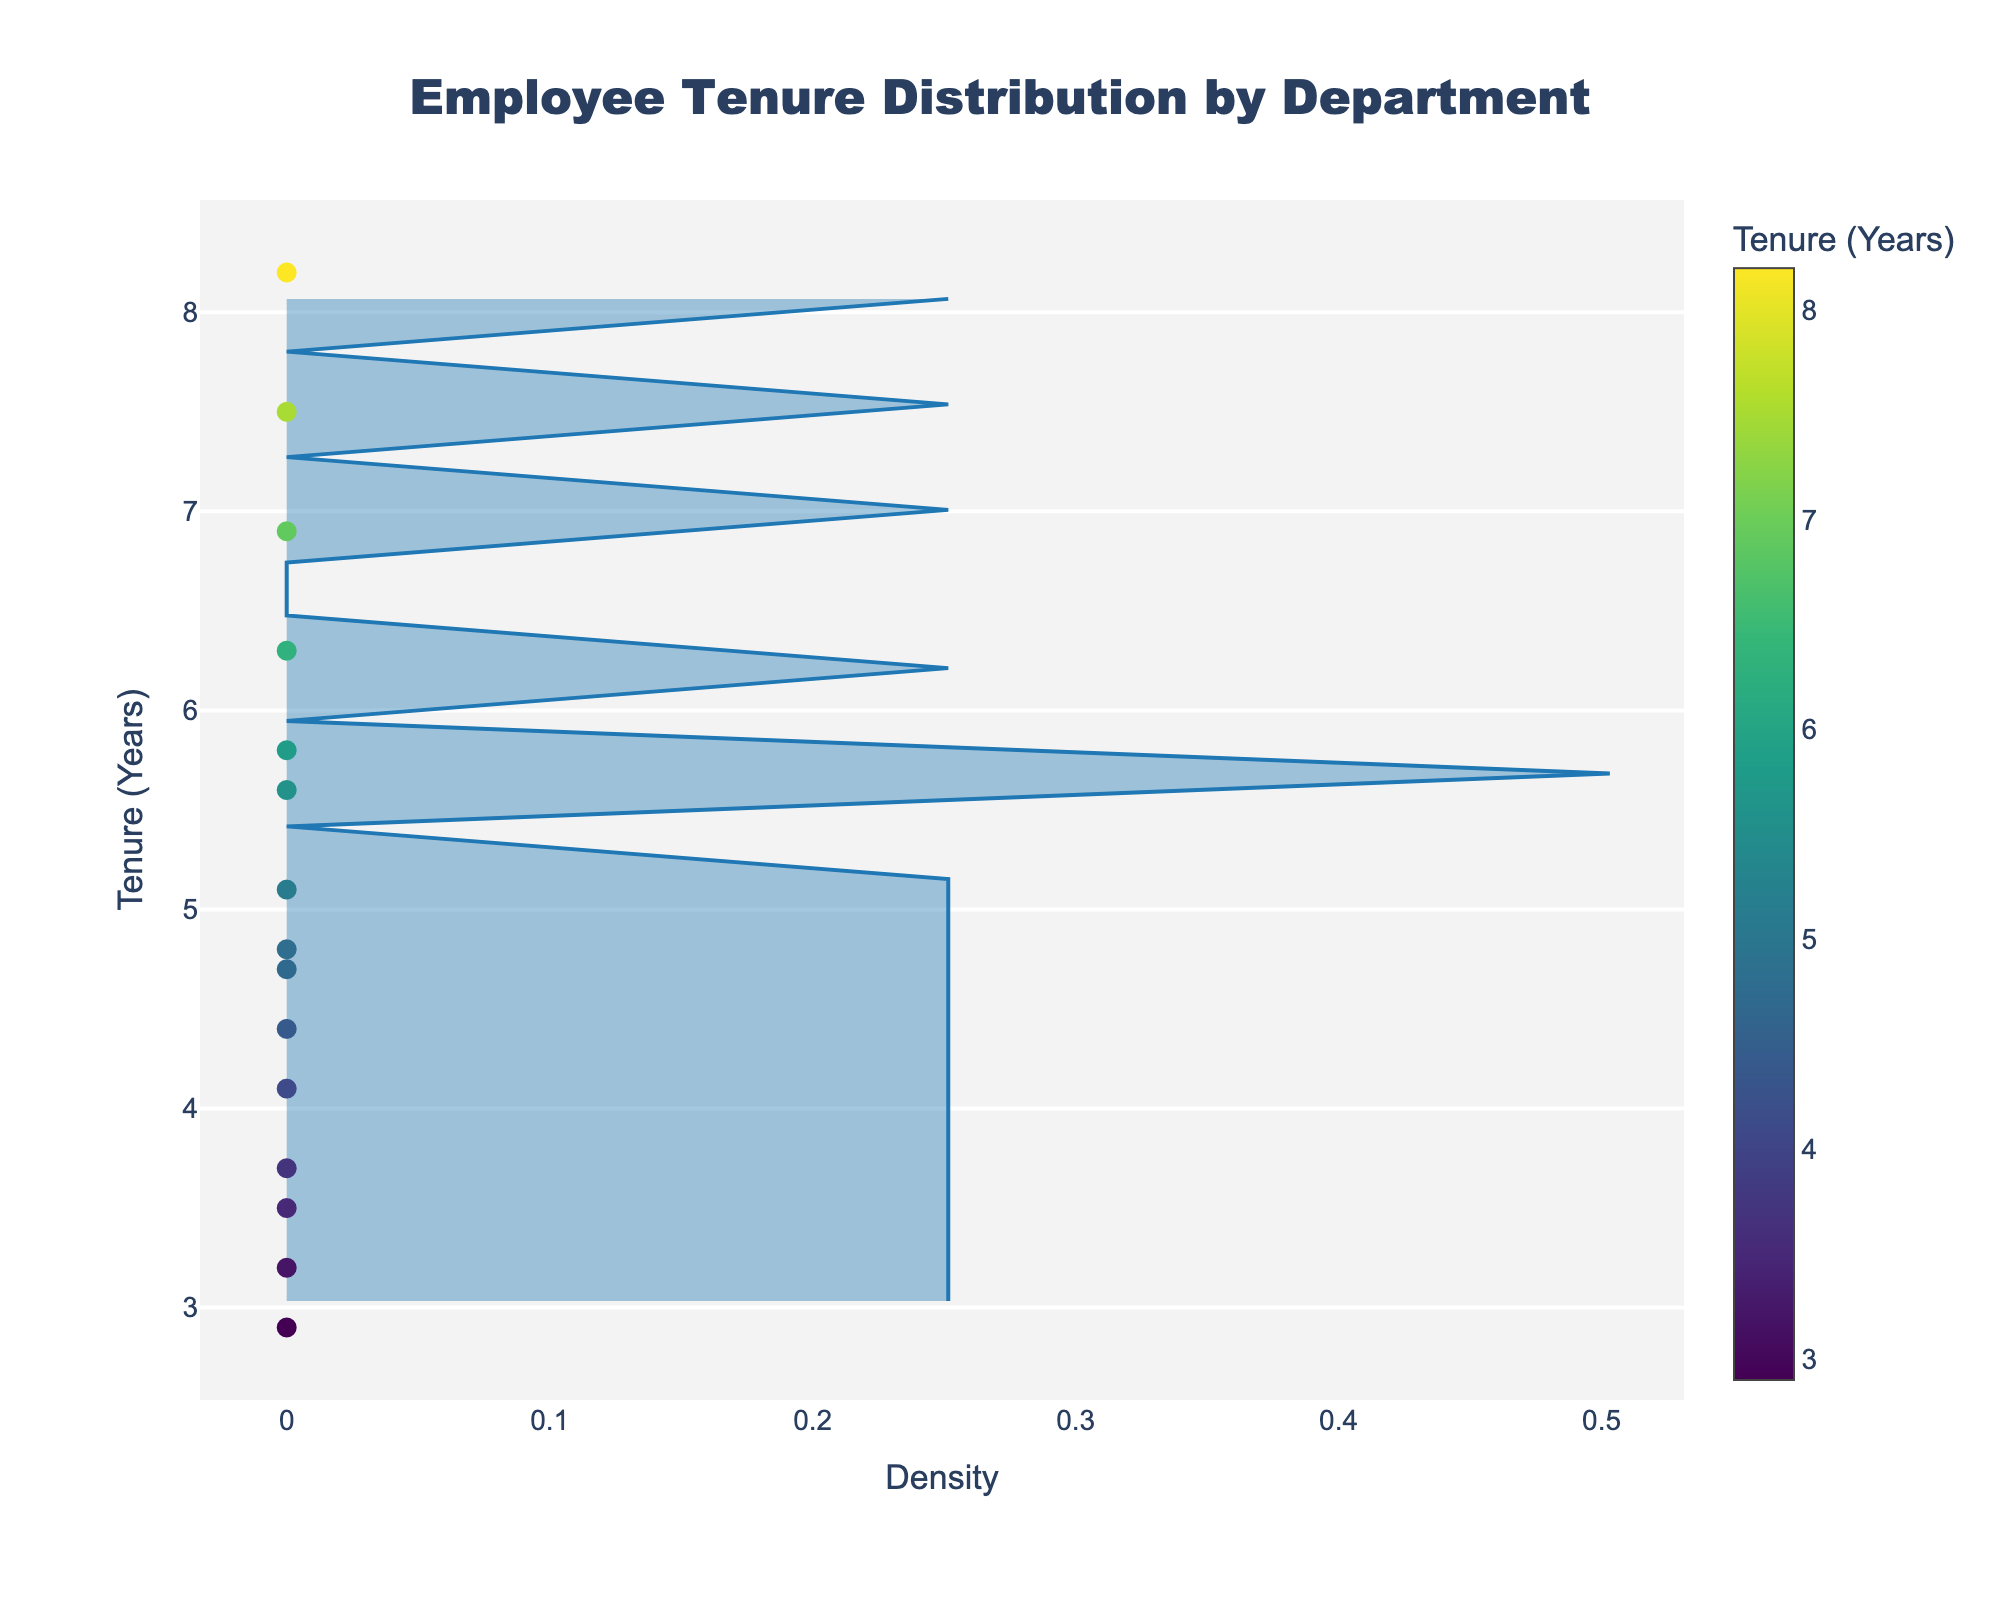What's the title of the plot? The title is usually located at the top of the plot, and it is used to describe what the plot is about. In this case, the title tells us that the plot is showing "Employee Tenure Distribution by Department".
Answer: Employee Tenure Distribution by Department What is the x-axis titled? The x-axis title is typically found below the x-axis line and informs us what the data points along the x-axis represent. In this plot, it indicates "Density".
Answer: Density How many departments are represented in the scatter plot? To find the number of departments, we count the distinct markers displayed vertically along the y-axis. Each marker represents a different department. There are 15 markers, each associated with a unique department.
Answer: 15 Which department has the highest tenure? The department with the highest tenure can be identified by looking at the topmost point on the y-axis, where each point represents a department’s tenure. In this plot, the highest tenure value is for the Legal department at 8.2 years.
Answer: Legal What is the average tenure across all departments? To calculate the average tenure, add the tenure values of all departments and divide by the number of departments: (3.2 + 7.5 + 5.8 + 4.1 + 2.9 + 6.3 + 3.7 + 8.2 + 5.6 + 4.4 + 6.9 + 4.8 + 3.5 + 5.1 + 4.7) / 15. The total tenure summed up is 76.7, and the average is 76.7 / 15 = 5.1133.
Answer: 5.1 years How dense is the tenure distribution around 5 years? To find the density around 5 years, look at the height of the density line on the x-axis at the 5-year mark on the y-axis. The density line is not extremely high or low; hence, it indicates a moderate density at around 5 years.
Answer: Moderate Which department has a lower tenure than the median tenure? First, find the median tenure by looking for the middle value in the sorted tenure list. The sorted tenure values are [2.9, 3.2, 3.5, 3.7, 4.1, 4.4, 4.7, 4.8, 5.1, 5.6, 5.8, 6.3, 6.9, 7.5, 8.2]. The middle value or median is 4.8 years. Departments with tenure below 4.8 are: Human Resources (3.2), Marketing (2.9), Customer Support (3.7), Public Relations (3.5).
Answer: Human Resources, Marketing, Customer Support, Public Relations 